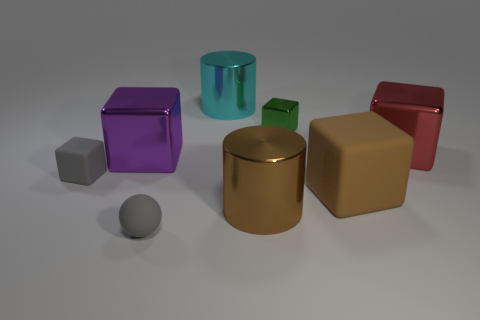There is a cube that is the same color as the sphere; what is its size?
Keep it short and to the point. Small. There is a large cylinder behind the small cube behind the large red block; what is its material?
Give a very brief answer. Metal. There is a object that is in front of the purple object and left of the tiny ball; what shape is it?
Ensure brevity in your answer.  Cube. The gray object that is the same shape as the big purple object is what size?
Provide a succinct answer. Small. Is the number of small green things to the left of the cyan shiny thing less than the number of large brown rubber blocks?
Your answer should be very brief. Yes. What size is the metallic cylinder in front of the green metallic object?
Your answer should be compact. Large. What is the color of the other matte object that is the same shape as the brown rubber object?
Give a very brief answer. Gray. What number of tiny rubber cylinders are the same color as the small sphere?
Offer a terse response. 0. Is there anything else that has the same shape as the large matte object?
Your answer should be compact. Yes. Are there any big metal things to the right of the big metallic cylinder that is in front of the large red object that is on the right side of the tiny shiny block?
Your response must be concise. Yes. 